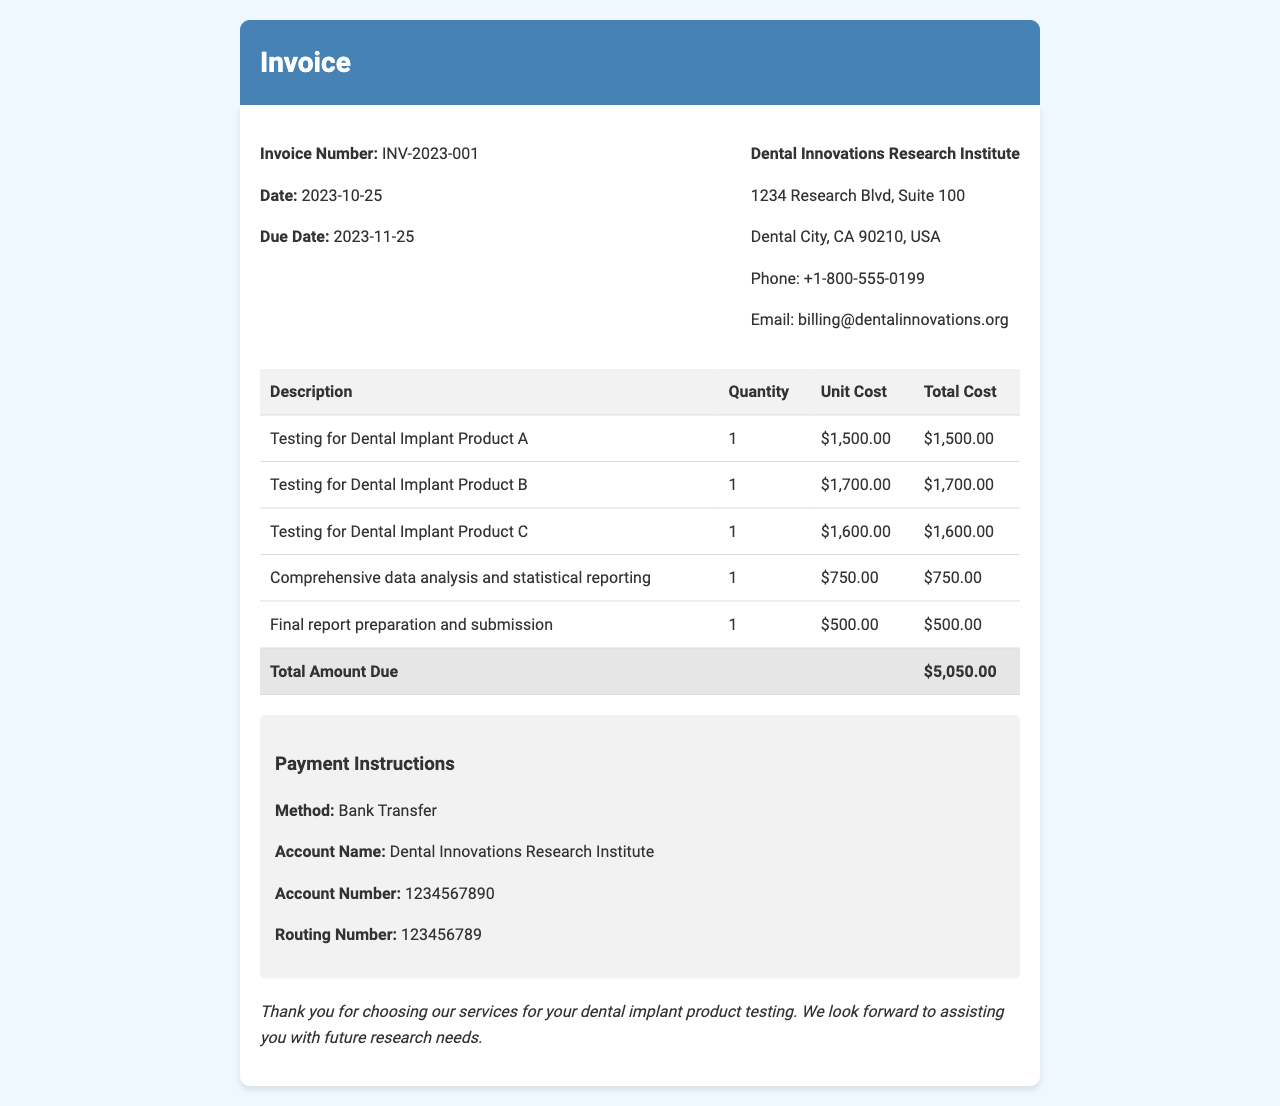What is the invoice number? The invoice number is found under the header section of the document.
Answer: INV-2023-001 What is the total amount due? The total amount due is listed at the bottom of the detailed costs section.
Answer: $5,050.00 When is the due date? The due date is listed directly under the invoice date.
Answer: 2023-11-25 What is the unit cost for testing Dental Implant Product B? The unit cost is specified next to the product description in the cost table.
Answer: $1,700.00 What services are included in the analysis fees? The analysis fees detail includes a specific item in the invoice that combines data analysis and reporting.
Answer: Comprehensive data analysis and statistical reporting, Final report preparation and submission What method of payment is accepted? The payment instructions section provides the accepted method for this invoice.
Answer: Bank Transfer Why is there a preparation fee listed? There is a fee for preparation to cover the costs associated with compiling and submitting the final report.
Answer: For final report preparation and submission What is the account number for payment? The account number is detailed in the payment instructions section.
Answer: 1234567890 How many products were tested according to this invoice? The quantity listed for each product tested indicates the number of products.
Answer: 3 